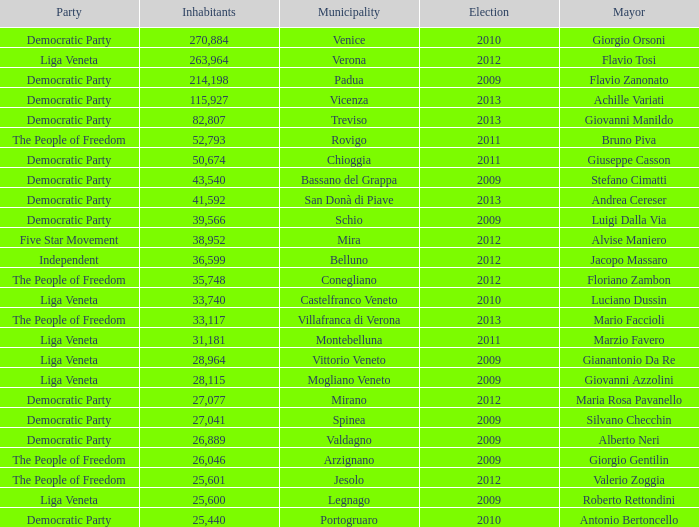Can you give me this table as a dict? {'header': ['Party', 'Inhabitants', 'Municipality', 'Election', 'Mayor'], 'rows': [['Democratic Party', '270,884', 'Venice', '2010', 'Giorgio Orsoni'], ['Liga Veneta', '263,964', 'Verona', '2012', 'Flavio Tosi'], ['Democratic Party', '214,198', 'Padua', '2009', 'Flavio Zanonato'], ['Democratic Party', '115,927', 'Vicenza', '2013', 'Achille Variati'], ['Democratic Party', '82,807', 'Treviso', '2013', 'Giovanni Manildo'], ['The People of Freedom', '52,793', 'Rovigo', '2011', 'Bruno Piva'], ['Democratic Party', '50,674', 'Chioggia', '2011', 'Giuseppe Casson'], ['Democratic Party', '43,540', 'Bassano del Grappa', '2009', 'Stefano Cimatti'], ['Democratic Party', '41,592', 'San Donà di Piave', '2013', 'Andrea Cereser'], ['Democratic Party', '39,566', 'Schio', '2009', 'Luigi Dalla Via'], ['Five Star Movement', '38,952', 'Mira', '2012', 'Alvise Maniero'], ['Independent', '36,599', 'Belluno', '2012', 'Jacopo Massaro'], ['The People of Freedom', '35,748', 'Conegliano', '2012', 'Floriano Zambon'], ['Liga Veneta', '33,740', 'Castelfranco Veneto', '2010', 'Luciano Dussin'], ['The People of Freedom', '33,117', 'Villafranca di Verona', '2013', 'Mario Faccioli'], ['Liga Veneta', '31,181', 'Montebelluna', '2011', 'Marzio Favero'], ['Liga Veneta', '28,964', 'Vittorio Veneto', '2009', 'Gianantonio Da Re'], ['Liga Veneta', '28,115', 'Mogliano Veneto', '2009', 'Giovanni Azzolini'], ['Democratic Party', '27,077', 'Mirano', '2012', 'Maria Rosa Pavanello'], ['Democratic Party', '27,041', 'Spinea', '2009', 'Silvano Checchin'], ['Democratic Party', '26,889', 'Valdagno', '2009', 'Alberto Neri'], ['The People of Freedom', '26,046', 'Arzignano', '2009', 'Giorgio Gentilin'], ['The People of Freedom', '25,601', 'Jesolo', '2012', 'Valerio Zoggia'], ['Liga Veneta', '25,600', 'Legnago', '2009', 'Roberto Rettondini'], ['Democratic Party', '25,440', 'Portogruaro', '2010', 'Antonio Bertoncello']]} In the election earlier than 2012 how many Inhabitants had a Party of five star movement? None. 